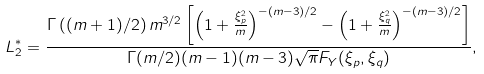Convert formula to latex. <formula><loc_0><loc_0><loc_500><loc_500>L _ { 2 } ^ { \ast } & = \frac { \Gamma \left ( ( m + 1 ) / 2 \right ) m ^ { 3 / 2 } \left [ \left ( 1 + \frac { \xi _ { p } ^ { 2 } } { m } \right ) ^ { - ( m - 3 ) / 2 } - \left ( 1 + \frac { \xi _ { q } ^ { 2 } } { m } \right ) ^ { - ( m - 3 ) / 2 } \right ] } { \Gamma ( m / 2 ) ( m - 1 ) ( m - 3 ) \sqrt { \pi } F _ { Y } ( \xi _ { p } , \xi _ { q } ) } ,</formula> 